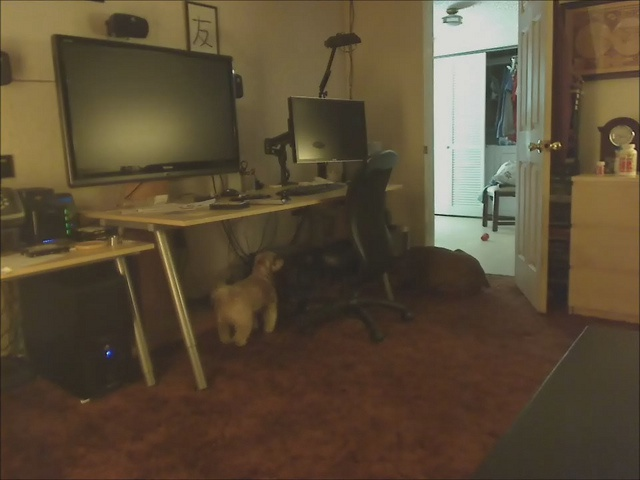Describe the objects in this image and their specific colors. I can see tv in black, darkgreen, and olive tones, chair in black, darkgreen, and gray tones, tv in black, darkgreen, and olive tones, dog in black, maroon, and olive tones, and chair in black and gray tones in this image. 